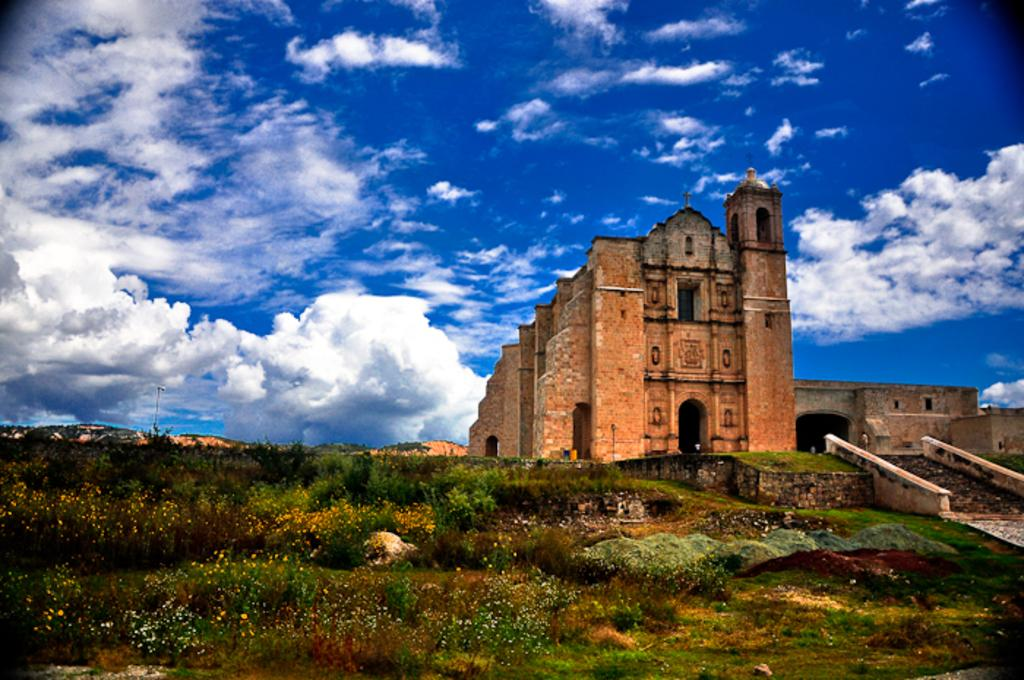What type of structure is present in the image? There is a building in the image. What type of vegetation can be seen in the image? There are trees and plants in the image. What part of the natural environment is visible in the image? The sky is visible in the image. How would you describe the sky in the image? The sky appears to be cloudy in the image. Where is the mailbox located in the image? There is no mailbox present in the image. What type of activity is happening at the cemetery in the image? There is no cemetery present in the image. 